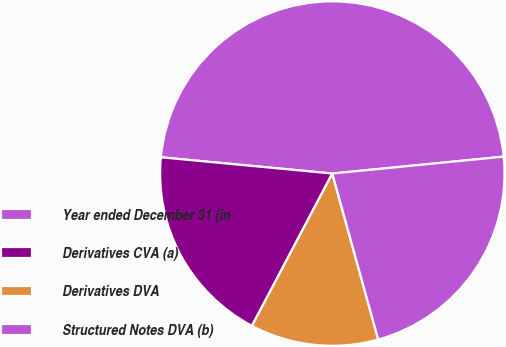<chart> <loc_0><loc_0><loc_500><loc_500><pie_chart><fcel>Year ended December 31 (in<fcel>Derivatives CVA (a)<fcel>Derivatives DVA<fcel>Structured Notes DVA (b)<nl><fcel>46.93%<fcel>18.78%<fcel>12.02%<fcel>22.27%<nl></chart> 